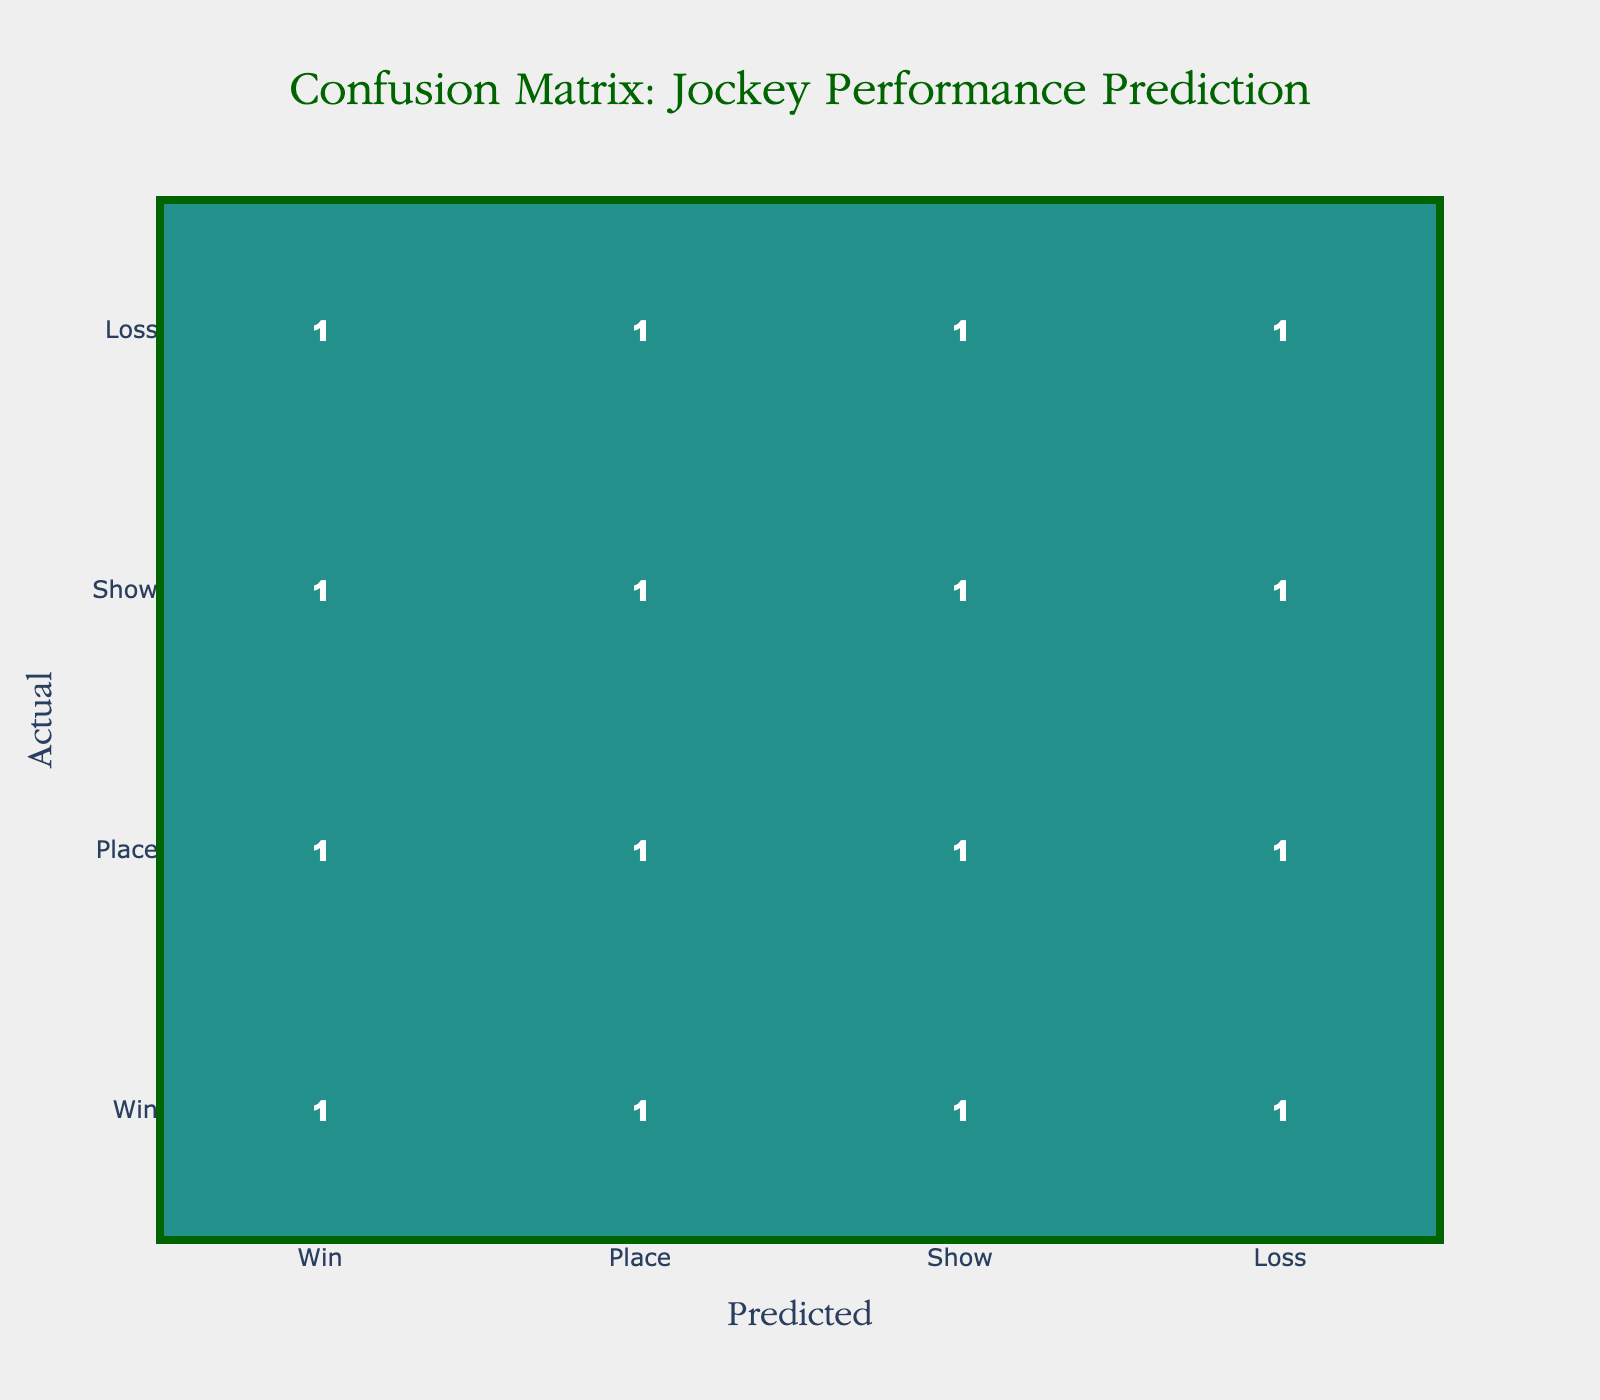What is the number of times "Win" was predicted when the actual outcome was "Win"? Looking at the confusion matrix, the intersection of the row "Win" and column "Win" gives the value, which is 1.
Answer: 1 What is the total number of "Loss" predictions? To find the total "Loss" predictions, sum the values in the "Loss" column (Loss, Win: 1, Loss, Place: 1, Loss, Show: 1, Loss, Loss: 1) resulting in 4.
Answer: 4 Is there a case where "Place" was predicted correctly? Checking the intersection of the row "Place" and column "Place", the value is 1, indicating that there is indeed one correct prediction for "Place".
Answer: Yes How many times did the model predict "Show" when the actual outcome was "Win"? In the confusion matrix, look at the intersection of the row "Win" and column "Show", which shows a value of 1. Hence, "Show" was predicted 1 time when the actual outcome was "Win".
Answer: 1 What percentage of "Loss" outcomes were correctly predicted as "Loss"? The actual "Loss" outcomes consist of 4 occurrences from the bottom row (1 from "Win", 1 from "Place", 1 from "Show", and 1 from "Loss"). Of these, only 1 is predicted as "Loss". Therefore, the percentage of correctly predicted "Loss" is (1/4) * 100 = 25%.
Answer: 25% Which prediction had the highest number of correct outcomes? By reviewing the diagonal values of the confusion matrix (1 for "Win", 1 for "Place", 1 for "Show", 1 for "Loss"), we find they all have the same count. However, since they all equally succeed, it makes it conclusive that the predictions are tied.
Answer: All predictions are tied What is the difference between the total predictions for "Win" and "Show"? Analysing the matrix, sum the predictions for "Win" (1+1+1+1 = 4) and for "Show" (1+1+1+1=4). The absolute difference is 4 - 4 = 0.
Answer: 0 Was "Show" predicted more often than "Place"? Check the total predictions for "Show" (1+1+1+1=4) and "Place" (1+1+1+1=4). They both are equal, thus "Show" was not predicted more often than "Place".
Answer: No How many times did the model incorrectly predict "Win"? For "Win", we see the values in "Place", "Show", and "Loss" which gives us a total of 3 incorrect predictions (1 in each). Therefore, it incorrectly predicted "Win" 3 times.
Answer: 3 What is the sum of all correct predictions? The correct predictions are found in the diagonal: 1 for "Win", 1 for "Place", 1 for "Show", and 1 for "Loss". Summing these gives us 1 + 1 + 1 + 1 = 4.
Answer: 4 